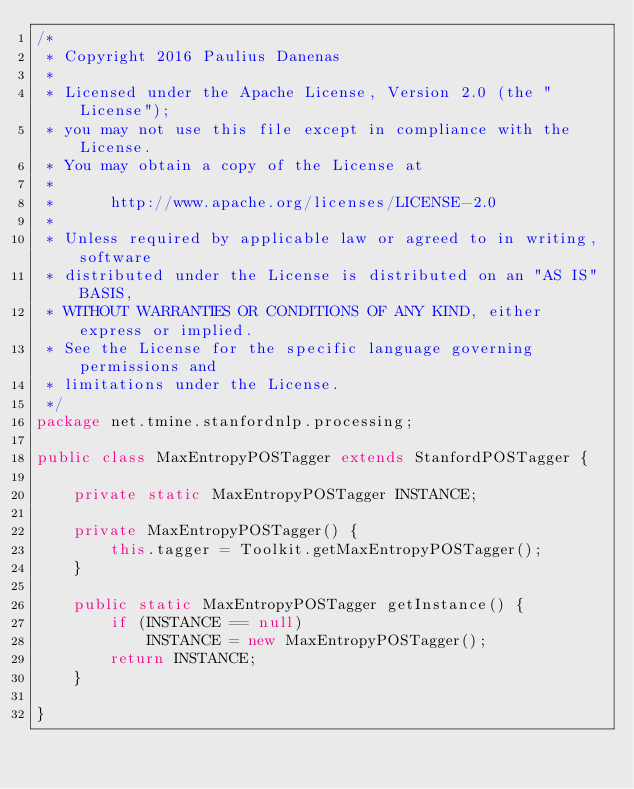Convert code to text. <code><loc_0><loc_0><loc_500><loc_500><_Java_>/*
 * Copyright 2016 Paulius Danenas
 *
 * Licensed under the Apache License, Version 2.0 (the "License");
 * you may not use this file except in compliance with the License.
 * You may obtain a copy of the License at
 *
 *      http://www.apache.org/licenses/LICENSE-2.0
 *
 * Unless required by applicable law or agreed to in writing, software
 * distributed under the License is distributed on an "AS IS" BASIS,
 * WITHOUT WARRANTIES OR CONDITIONS OF ANY KIND, either express or implied.
 * See the License for the specific language governing permissions and
 * limitations under the License.
 */
package net.tmine.stanfordnlp.processing;

public class MaxEntropyPOSTagger extends StanfordPOSTagger {
    
    private static MaxEntropyPOSTagger INSTANCE;
    
    private MaxEntropyPOSTagger() {
        this.tagger = Toolkit.getMaxEntropyPOSTagger();
    }
    
    public static MaxEntropyPOSTagger getInstance() {
        if (INSTANCE == null)
            INSTANCE = new MaxEntropyPOSTagger();
        return INSTANCE;
    }
    
}
</code> 